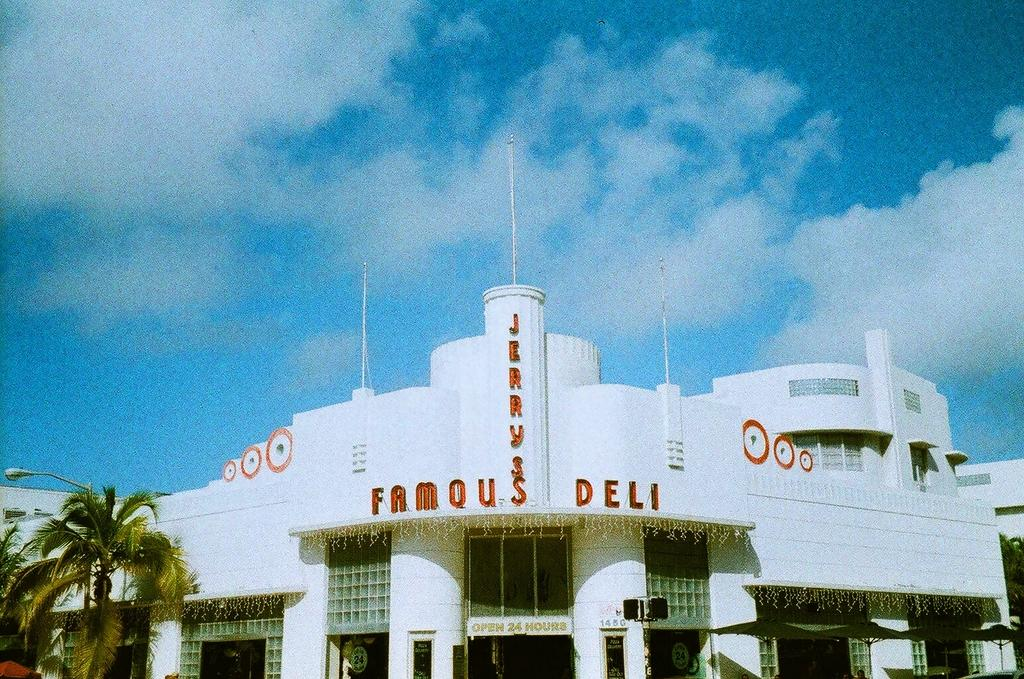<image>
Summarize the visual content of the image. white building that reads famous deli in red 